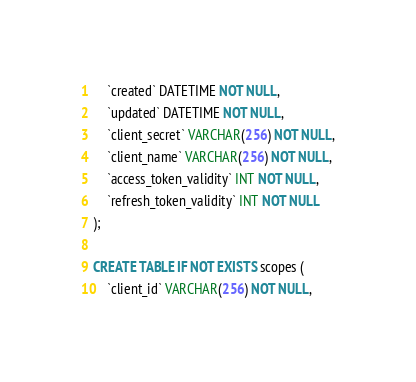Convert code to text. <code><loc_0><loc_0><loc_500><loc_500><_SQL_>    `created` DATETIME NOT NULL,
    `updated` DATETIME NOT NULL,
    `client_secret` VARCHAR(256) NOT NULL,
    `client_name` VARCHAR(256) NOT NULL,
    `access_token_validity` INT NOT NULL,
    `refresh_token_validity` INT NOT NULL
);

CREATE TABLE IF NOT EXISTS scopes (
    `client_id` VARCHAR(256) NOT NULL,</code> 